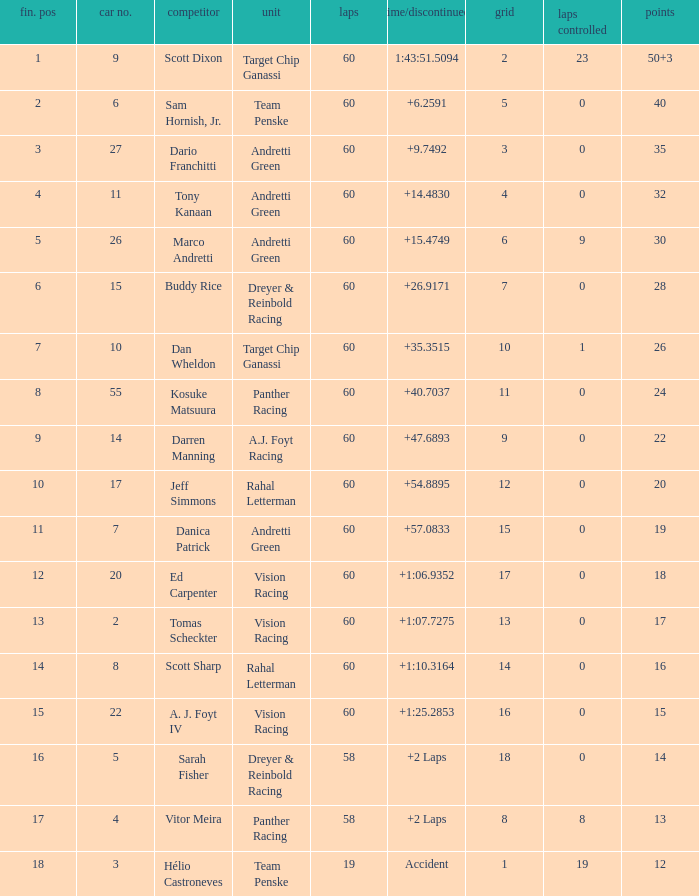Name the total number of grid for 30 1.0. 